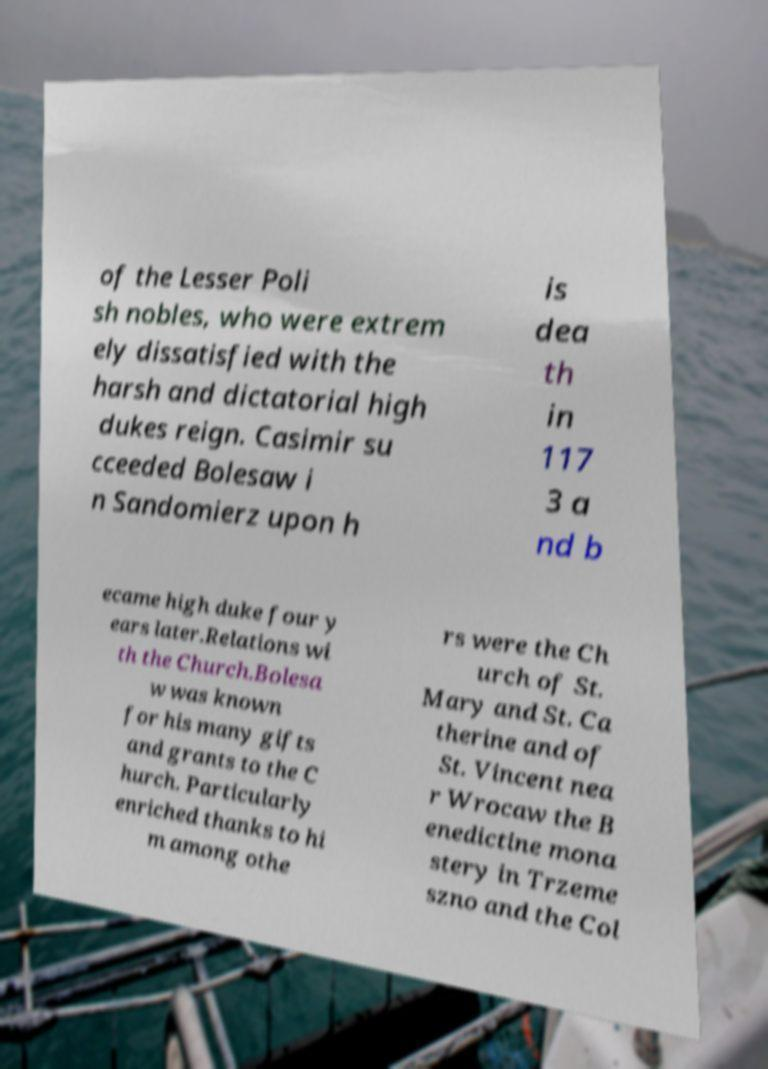Please identify and transcribe the text found in this image. of the Lesser Poli sh nobles, who were extrem ely dissatisfied with the harsh and dictatorial high dukes reign. Casimir su cceeded Bolesaw i n Sandomierz upon h is dea th in 117 3 a nd b ecame high duke four y ears later.Relations wi th the Church.Bolesa w was known for his many gifts and grants to the C hurch. Particularly enriched thanks to hi m among othe rs were the Ch urch of St. Mary and St. Ca therine and of St. Vincent nea r Wrocaw the B enedictine mona stery in Trzeme szno and the Col 